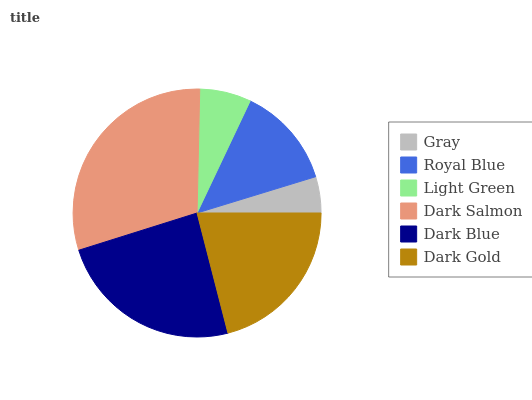Is Gray the minimum?
Answer yes or no. Yes. Is Dark Salmon the maximum?
Answer yes or no. Yes. Is Royal Blue the minimum?
Answer yes or no. No. Is Royal Blue the maximum?
Answer yes or no. No. Is Royal Blue greater than Gray?
Answer yes or no. Yes. Is Gray less than Royal Blue?
Answer yes or no. Yes. Is Gray greater than Royal Blue?
Answer yes or no. No. Is Royal Blue less than Gray?
Answer yes or no. No. Is Dark Gold the high median?
Answer yes or no. Yes. Is Royal Blue the low median?
Answer yes or no. Yes. Is Dark Salmon the high median?
Answer yes or no. No. Is Dark Gold the low median?
Answer yes or no. No. 